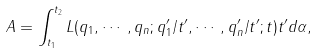<formula> <loc_0><loc_0><loc_500><loc_500>A = \int _ { t _ { 1 } } ^ { t _ { 2 } } L ( q _ { 1 } , \cdots , q _ { n } ; q _ { 1 } ^ { \prime } / t ^ { \prime } , \cdots , q _ { n } ^ { \prime } / t ^ { \prime } ; t ) t ^ { \prime } d \alpha ,</formula> 